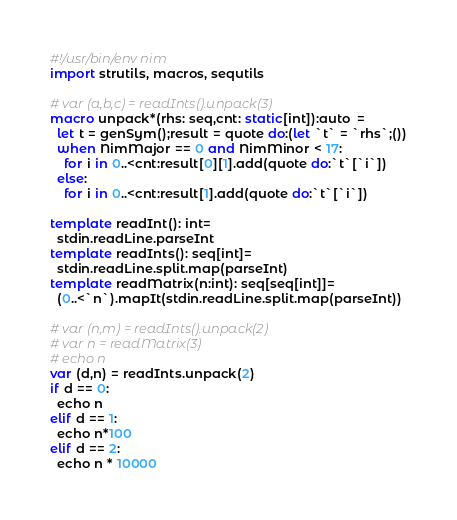<code> <loc_0><loc_0><loc_500><loc_500><_Nim_>#!/usr/bin/env nim
import strutils, macros, sequtils

# var (a,b,c) = readInts().unpack(3)
macro unpack*(rhs: seq,cnt: static[int]):auto  =
  let t = genSym();result = quote do:(let `t` = `rhs`;())
  when NimMajor == 0 and NimMinor < 17:
    for i in 0..<cnt:result[0][1].add(quote do:`t`[`i`])
  else:
    for i in 0..<cnt:result[1].add(quote do:`t`[`i`])

template readInt(): int=
  stdin.readLine.parseInt
template readInts(): seq[int]=
  stdin.readLine.split.map(parseInt)
template readMatrix(n:int): seq[seq[int]]=
  (0..<`n`).mapIt(stdin.readLine.split.map(parseInt))

# var (n,m) = readInts().unpack(2)
# var n = readMatrix(3)
# echo n
var (d,n) = readInts.unpack(2)
if d == 0:
  echo n
elif d == 1:
  echo n*100
elif d == 2:
  echo n * 10000</code> 